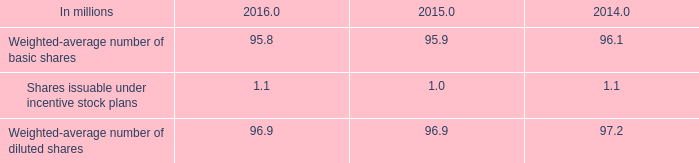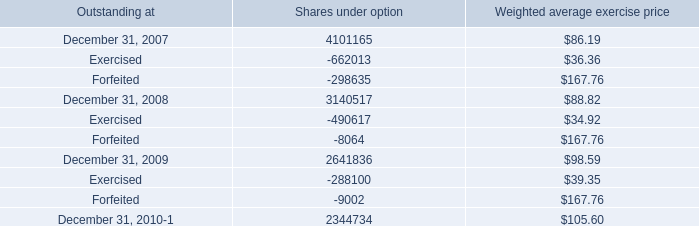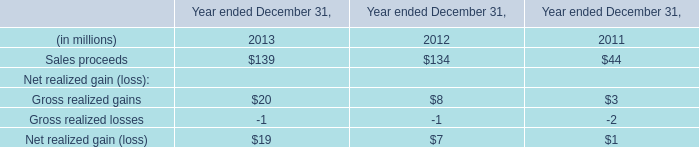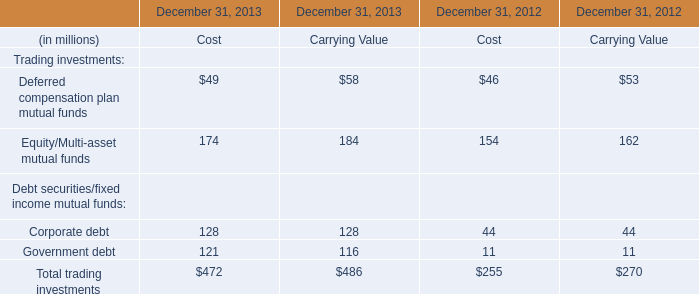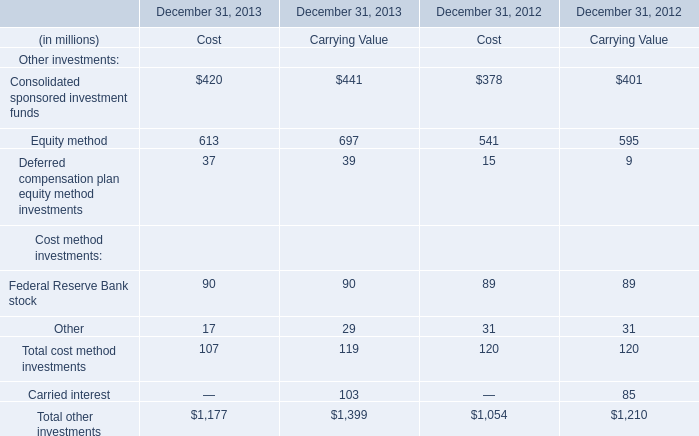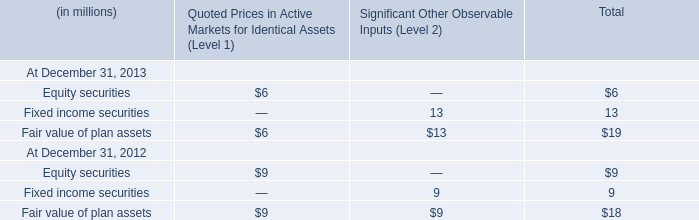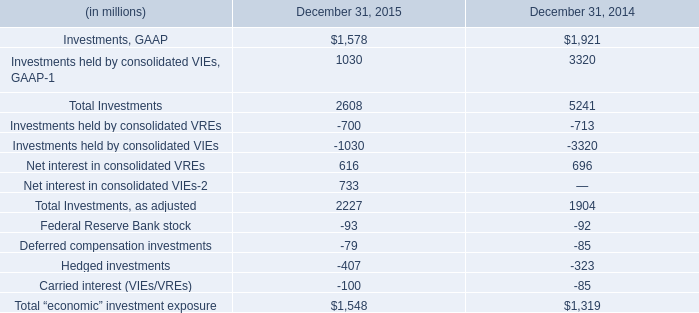What's the growth rate of Corporate debt in 2013? (in %) 
Computations: ((128 - 44) / 128)
Answer: 0.65625. 